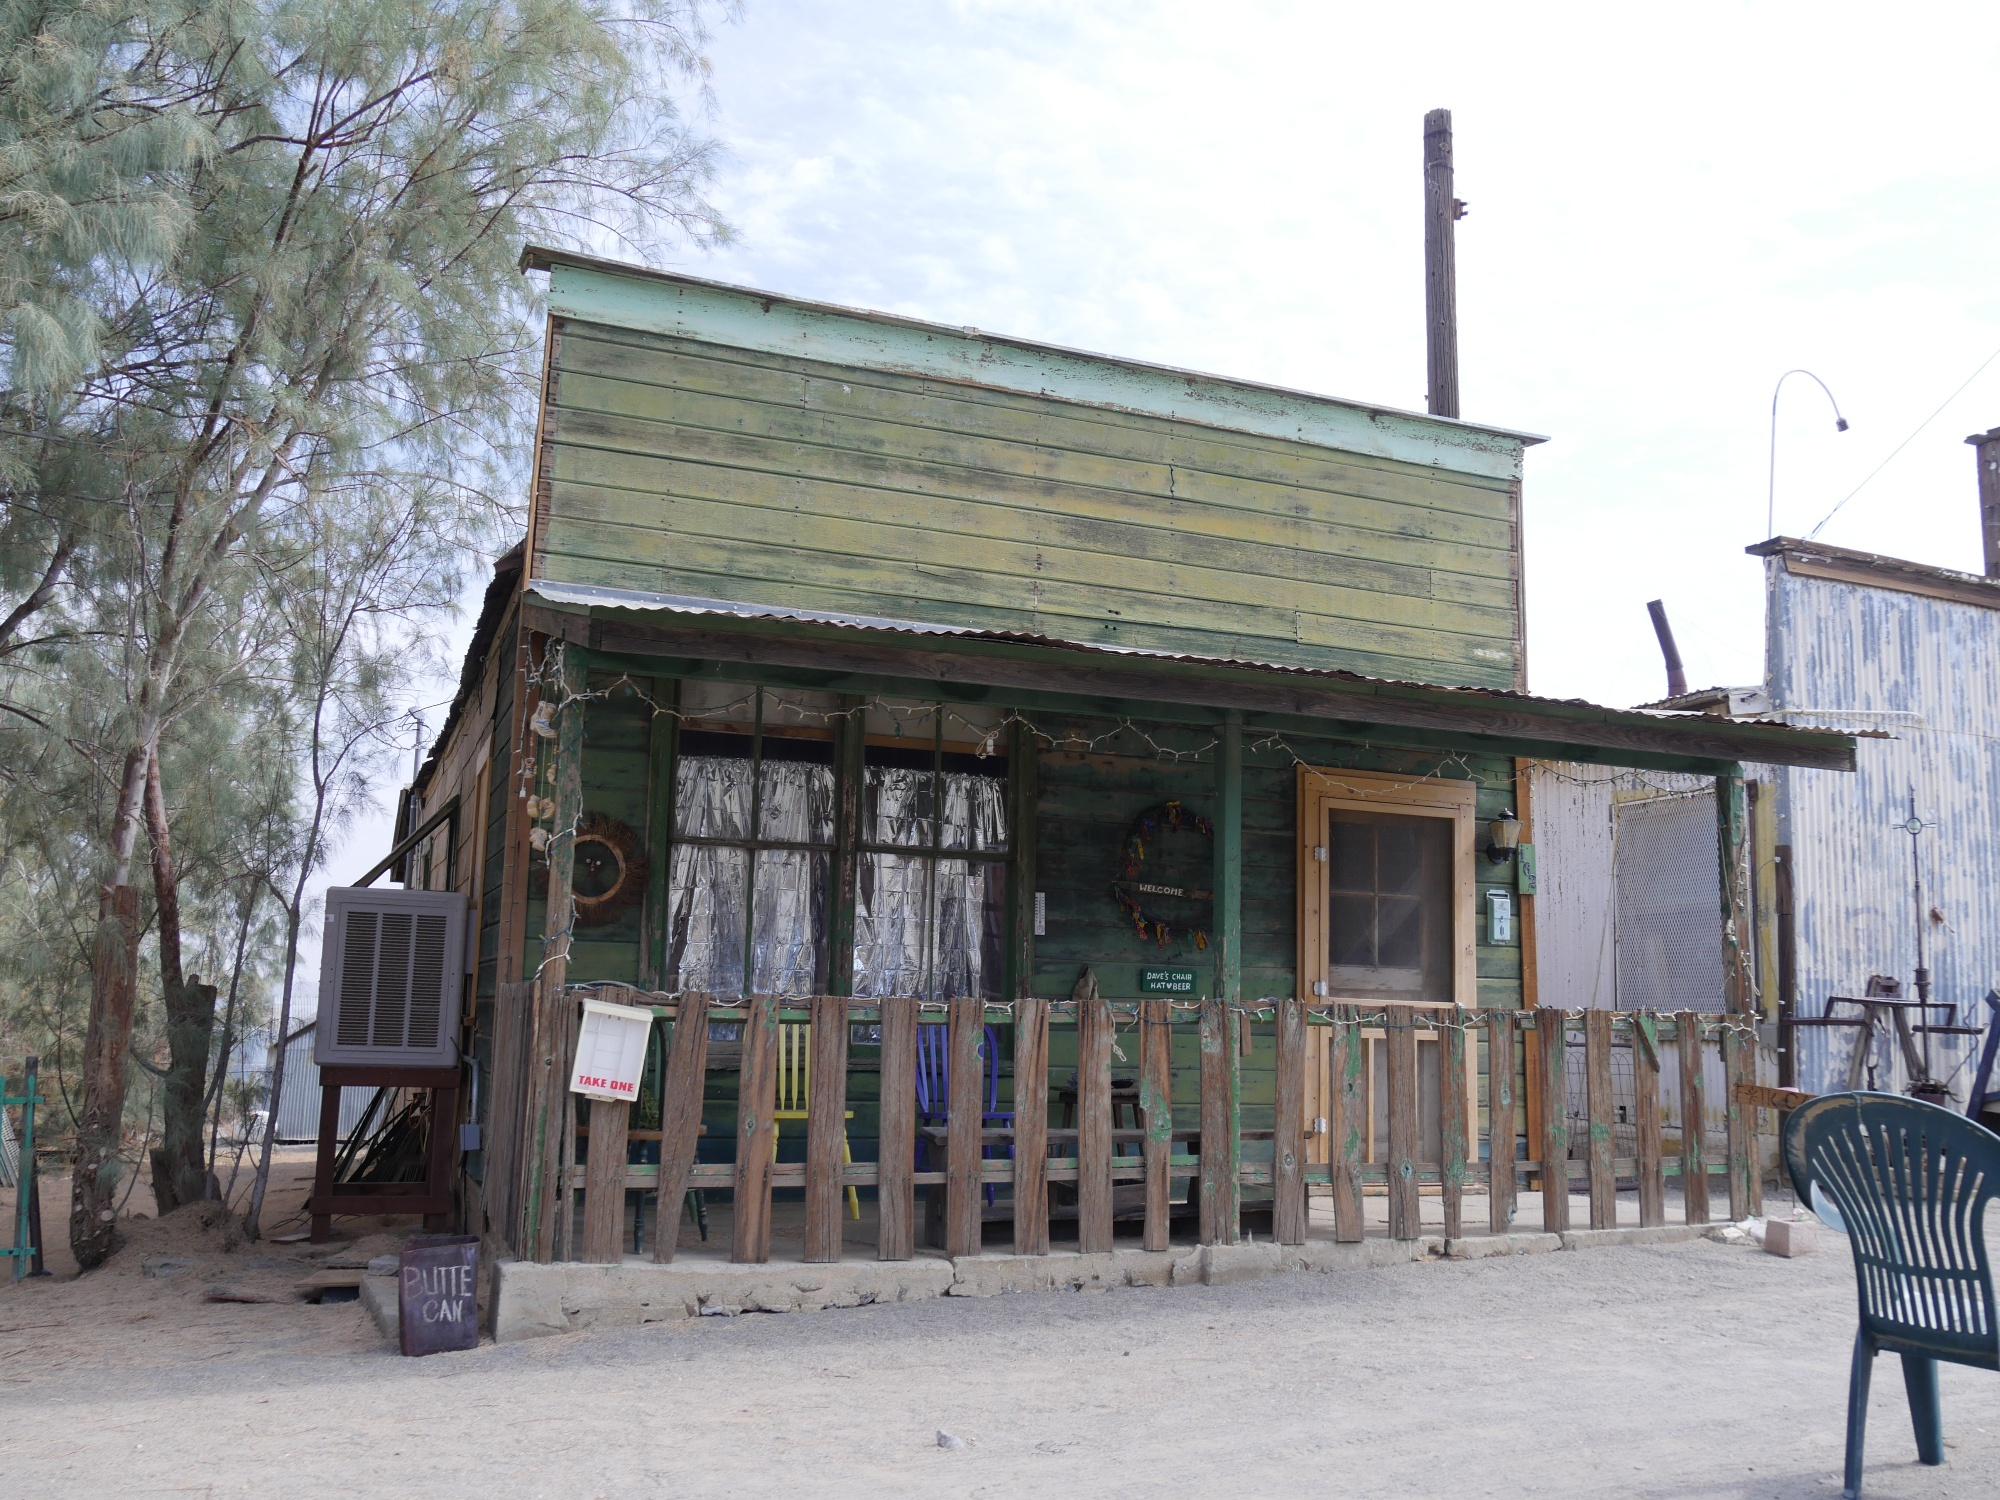Who might have lived or worked in this building? This building may have once been home to a family or served as a small business establishment along Route 66. Given its rustic charm, it might have been a quaint roadside café or a small general store for travelers. The people who occupied it likely valued community and hard work, finding joy in simple comforts and the camaraderie of passersby. 